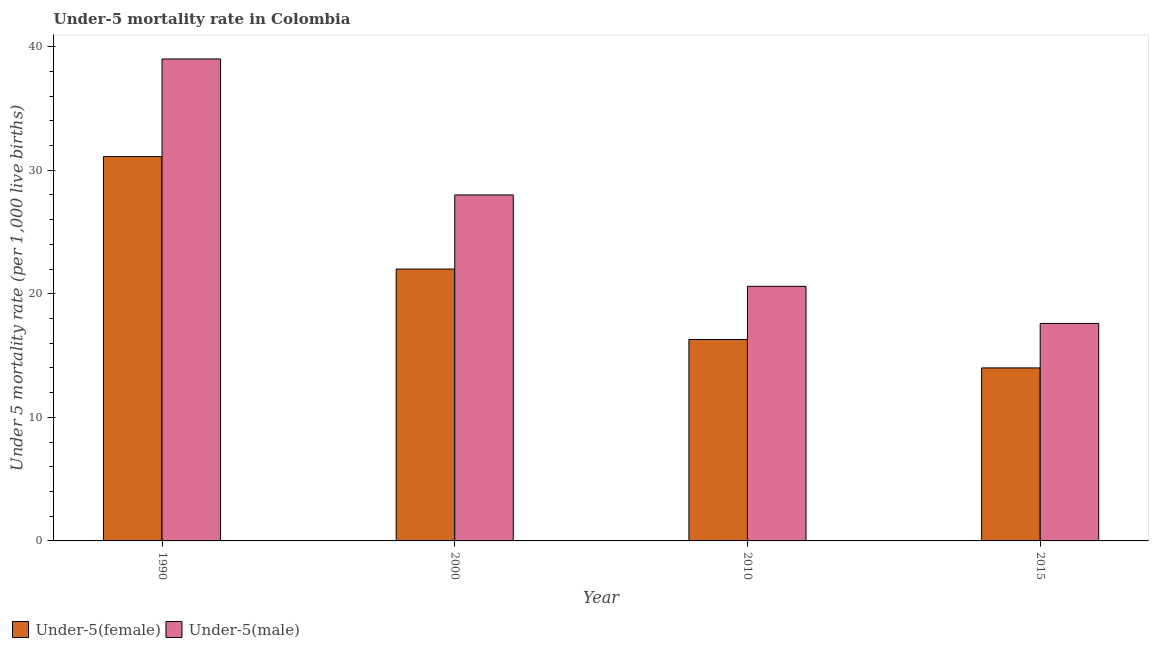How many different coloured bars are there?
Ensure brevity in your answer.  2. Are the number of bars per tick equal to the number of legend labels?
Make the answer very short. Yes. Are the number of bars on each tick of the X-axis equal?
Provide a succinct answer. Yes. What is the label of the 4th group of bars from the left?
Provide a succinct answer. 2015. In how many cases, is the number of bars for a given year not equal to the number of legend labels?
Provide a succinct answer. 0. Across all years, what is the maximum under-5 male mortality rate?
Offer a terse response. 39. In which year was the under-5 female mortality rate minimum?
Keep it short and to the point. 2015. What is the total under-5 male mortality rate in the graph?
Your response must be concise. 105.2. What is the difference between the under-5 male mortality rate in 2010 and that in 2015?
Give a very brief answer. 3. What is the difference between the under-5 female mortality rate in 1990 and the under-5 male mortality rate in 2015?
Make the answer very short. 17.1. What is the average under-5 male mortality rate per year?
Provide a short and direct response. 26.3. In how many years, is the under-5 female mortality rate greater than 10?
Keep it short and to the point. 4. What is the ratio of the under-5 female mortality rate in 1990 to that in 2015?
Your answer should be compact. 2.22. Is the under-5 female mortality rate in 1990 less than that in 2010?
Provide a succinct answer. No. Is the difference between the under-5 female mortality rate in 1990 and 2015 greater than the difference between the under-5 male mortality rate in 1990 and 2015?
Make the answer very short. No. What is the difference between the highest and the lowest under-5 male mortality rate?
Give a very brief answer. 21.4. What does the 2nd bar from the left in 1990 represents?
Your answer should be compact. Under-5(male). What does the 1st bar from the right in 2010 represents?
Make the answer very short. Under-5(male). Are all the bars in the graph horizontal?
Ensure brevity in your answer.  No. Are the values on the major ticks of Y-axis written in scientific E-notation?
Your answer should be compact. No. Does the graph contain any zero values?
Your response must be concise. No. Where does the legend appear in the graph?
Provide a succinct answer. Bottom left. How are the legend labels stacked?
Ensure brevity in your answer.  Horizontal. What is the title of the graph?
Ensure brevity in your answer.  Under-5 mortality rate in Colombia. Does "Time to export" appear as one of the legend labels in the graph?
Your answer should be very brief. No. What is the label or title of the X-axis?
Keep it short and to the point. Year. What is the label or title of the Y-axis?
Give a very brief answer. Under 5 mortality rate (per 1,0 live births). What is the Under 5 mortality rate (per 1,000 live births) of Under-5(female) in 1990?
Your answer should be very brief. 31.1. What is the Under 5 mortality rate (per 1,000 live births) of Under-5(female) in 2010?
Provide a succinct answer. 16.3. What is the Under 5 mortality rate (per 1,000 live births) of Under-5(male) in 2010?
Offer a very short reply. 20.6. What is the Under 5 mortality rate (per 1,000 live births) in Under-5(female) in 2015?
Ensure brevity in your answer.  14. What is the Under 5 mortality rate (per 1,000 live births) in Under-5(male) in 2015?
Your answer should be compact. 17.6. Across all years, what is the maximum Under 5 mortality rate (per 1,000 live births) of Under-5(female)?
Your answer should be compact. 31.1. Across all years, what is the minimum Under 5 mortality rate (per 1,000 live births) in Under-5(female)?
Ensure brevity in your answer.  14. Across all years, what is the minimum Under 5 mortality rate (per 1,000 live births) in Under-5(male)?
Your answer should be very brief. 17.6. What is the total Under 5 mortality rate (per 1,000 live births) of Under-5(female) in the graph?
Provide a succinct answer. 83.4. What is the total Under 5 mortality rate (per 1,000 live births) in Under-5(male) in the graph?
Give a very brief answer. 105.2. What is the difference between the Under 5 mortality rate (per 1,000 live births) in Under-5(female) in 1990 and that in 2000?
Your answer should be compact. 9.1. What is the difference between the Under 5 mortality rate (per 1,000 live births) in Under-5(female) in 1990 and that in 2010?
Your response must be concise. 14.8. What is the difference between the Under 5 mortality rate (per 1,000 live births) in Under-5(male) in 1990 and that in 2010?
Provide a short and direct response. 18.4. What is the difference between the Under 5 mortality rate (per 1,000 live births) in Under-5(female) in 1990 and that in 2015?
Your answer should be compact. 17.1. What is the difference between the Under 5 mortality rate (per 1,000 live births) in Under-5(male) in 1990 and that in 2015?
Give a very brief answer. 21.4. What is the difference between the Under 5 mortality rate (per 1,000 live births) of Under-5(female) in 2000 and that in 2010?
Offer a terse response. 5.7. What is the difference between the Under 5 mortality rate (per 1,000 live births) of Under-5(male) in 2000 and that in 2010?
Your response must be concise. 7.4. What is the difference between the Under 5 mortality rate (per 1,000 live births) of Under-5(female) in 2000 and that in 2015?
Offer a terse response. 8. What is the difference between the Under 5 mortality rate (per 1,000 live births) in Under-5(male) in 2010 and that in 2015?
Keep it short and to the point. 3. What is the difference between the Under 5 mortality rate (per 1,000 live births) in Under-5(female) in 2000 and the Under 5 mortality rate (per 1,000 live births) in Under-5(male) in 2010?
Provide a short and direct response. 1.4. What is the average Under 5 mortality rate (per 1,000 live births) of Under-5(female) per year?
Ensure brevity in your answer.  20.85. What is the average Under 5 mortality rate (per 1,000 live births) in Under-5(male) per year?
Your answer should be compact. 26.3. In the year 1990, what is the difference between the Under 5 mortality rate (per 1,000 live births) of Under-5(female) and Under 5 mortality rate (per 1,000 live births) of Under-5(male)?
Your response must be concise. -7.9. In the year 2000, what is the difference between the Under 5 mortality rate (per 1,000 live births) of Under-5(female) and Under 5 mortality rate (per 1,000 live births) of Under-5(male)?
Keep it short and to the point. -6. In the year 2010, what is the difference between the Under 5 mortality rate (per 1,000 live births) of Under-5(female) and Under 5 mortality rate (per 1,000 live births) of Under-5(male)?
Keep it short and to the point. -4.3. What is the ratio of the Under 5 mortality rate (per 1,000 live births) of Under-5(female) in 1990 to that in 2000?
Your answer should be very brief. 1.41. What is the ratio of the Under 5 mortality rate (per 1,000 live births) of Under-5(male) in 1990 to that in 2000?
Provide a succinct answer. 1.39. What is the ratio of the Under 5 mortality rate (per 1,000 live births) of Under-5(female) in 1990 to that in 2010?
Make the answer very short. 1.91. What is the ratio of the Under 5 mortality rate (per 1,000 live births) in Under-5(male) in 1990 to that in 2010?
Offer a terse response. 1.89. What is the ratio of the Under 5 mortality rate (per 1,000 live births) in Under-5(female) in 1990 to that in 2015?
Provide a succinct answer. 2.22. What is the ratio of the Under 5 mortality rate (per 1,000 live births) in Under-5(male) in 1990 to that in 2015?
Ensure brevity in your answer.  2.22. What is the ratio of the Under 5 mortality rate (per 1,000 live births) of Under-5(female) in 2000 to that in 2010?
Give a very brief answer. 1.35. What is the ratio of the Under 5 mortality rate (per 1,000 live births) of Under-5(male) in 2000 to that in 2010?
Your answer should be very brief. 1.36. What is the ratio of the Under 5 mortality rate (per 1,000 live births) in Under-5(female) in 2000 to that in 2015?
Ensure brevity in your answer.  1.57. What is the ratio of the Under 5 mortality rate (per 1,000 live births) in Under-5(male) in 2000 to that in 2015?
Make the answer very short. 1.59. What is the ratio of the Under 5 mortality rate (per 1,000 live births) in Under-5(female) in 2010 to that in 2015?
Your answer should be very brief. 1.16. What is the ratio of the Under 5 mortality rate (per 1,000 live births) in Under-5(male) in 2010 to that in 2015?
Your response must be concise. 1.17. What is the difference between the highest and the lowest Under 5 mortality rate (per 1,000 live births) in Under-5(female)?
Ensure brevity in your answer.  17.1. What is the difference between the highest and the lowest Under 5 mortality rate (per 1,000 live births) of Under-5(male)?
Your answer should be compact. 21.4. 